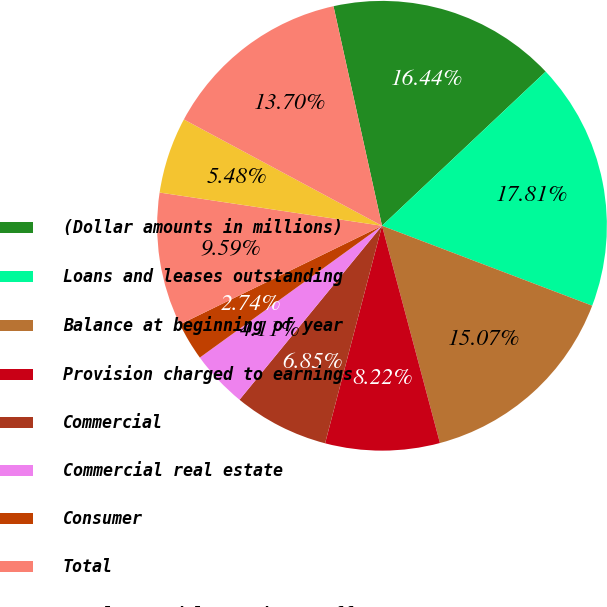<chart> <loc_0><loc_0><loc_500><loc_500><pie_chart><fcel>(Dollar amounts in millions)<fcel>Loans and leases outstanding<fcel>Balance at beginning of year<fcel>Provision charged to earnings<fcel>Commercial<fcel>Commercial real estate<fcel>Consumer<fcel>Total<fcel>Net loan and lease charge-offs<fcel>Balance at end of year<nl><fcel>16.44%<fcel>17.81%<fcel>15.07%<fcel>8.22%<fcel>6.85%<fcel>4.11%<fcel>2.74%<fcel>9.59%<fcel>5.48%<fcel>13.7%<nl></chart> 